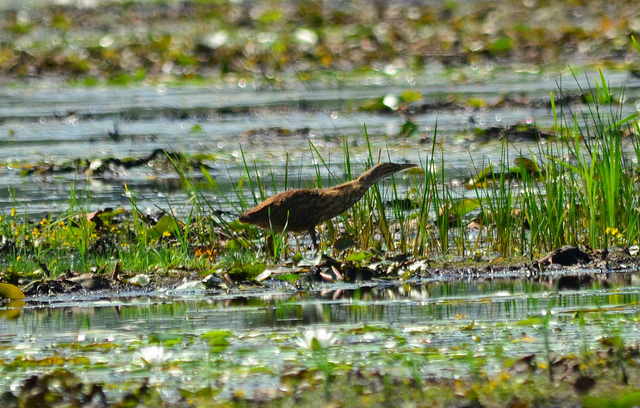<image>What is around the bird? It is unclear what is around the bird. It could be grass, water or plants. What is around the bird? I don't know what is around the bird. It can be grass, water, water and grass, or plants. 